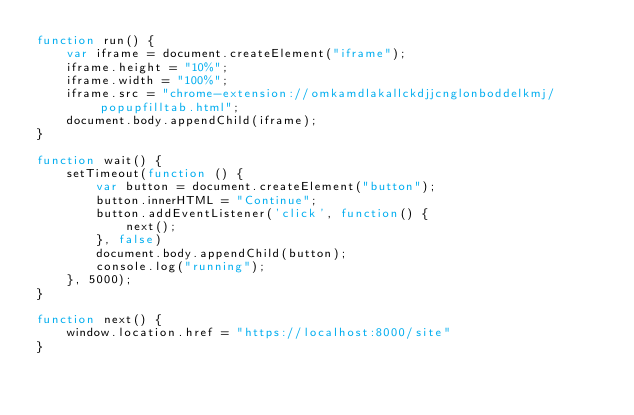Convert code to text. <code><loc_0><loc_0><loc_500><loc_500><_JavaScript_>function run() {
    var iframe = document.createElement("iframe");
    iframe.height = "10%";
    iframe.width = "100%";
    iframe.src = "chrome-extension://omkamdlakallckdjjcnglonboddelkmj/popupfilltab.html";
    document.body.appendChild(iframe);
}

function wait() {
    setTimeout(function () {
        var button = document.createElement("button");
        button.innerHTML = "Continue";
        button.addEventListener('click', function() {
            next();
        }, false)
        document.body.appendChild(button);
        console.log("running");
    }, 5000);
}

function next() {
    window.location.href = "https://localhost:8000/site"
}</code> 